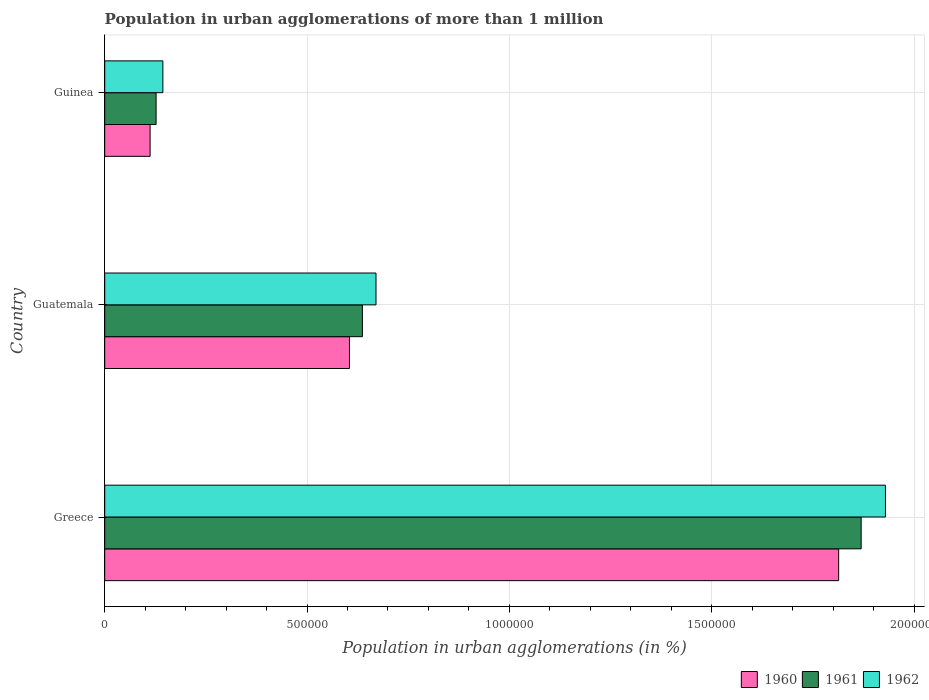How many different coloured bars are there?
Provide a succinct answer. 3. Are the number of bars on each tick of the Y-axis equal?
Your answer should be compact. Yes. How many bars are there on the 1st tick from the top?
Your response must be concise. 3. How many bars are there on the 2nd tick from the bottom?
Provide a short and direct response. 3. What is the label of the 1st group of bars from the top?
Your answer should be very brief. Guinea. In how many cases, is the number of bars for a given country not equal to the number of legend labels?
Your answer should be very brief. 0. What is the population in urban agglomerations in 1962 in Greece?
Your answer should be very brief. 1.93e+06. Across all countries, what is the maximum population in urban agglomerations in 1961?
Offer a terse response. 1.87e+06. Across all countries, what is the minimum population in urban agglomerations in 1962?
Ensure brevity in your answer.  1.44e+05. In which country was the population in urban agglomerations in 1960 minimum?
Give a very brief answer. Guinea. What is the total population in urban agglomerations in 1962 in the graph?
Offer a very short reply. 2.74e+06. What is the difference between the population in urban agglomerations in 1962 in Greece and that in Guatemala?
Make the answer very short. 1.26e+06. What is the difference between the population in urban agglomerations in 1961 in Guatemala and the population in urban agglomerations in 1960 in Guinea?
Your response must be concise. 5.25e+05. What is the average population in urban agglomerations in 1961 per country?
Your answer should be compact. 8.78e+05. What is the difference between the population in urban agglomerations in 1961 and population in urban agglomerations in 1960 in Guatemala?
Offer a terse response. 3.19e+04. What is the ratio of the population in urban agglomerations in 1961 in Greece to that in Guatemala?
Offer a very short reply. 2.94. Is the population in urban agglomerations in 1960 in Greece less than that in Guinea?
Provide a short and direct response. No. Is the difference between the population in urban agglomerations in 1961 in Greece and Guinea greater than the difference between the population in urban agglomerations in 1960 in Greece and Guinea?
Make the answer very short. Yes. What is the difference between the highest and the second highest population in urban agglomerations in 1961?
Your answer should be very brief. 1.23e+06. What is the difference between the highest and the lowest population in urban agglomerations in 1960?
Give a very brief answer. 1.70e+06. Is the sum of the population in urban agglomerations in 1960 in Greece and Guatemala greater than the maximum population in urban agglomerations in 1962 across all countries?
Your response must be concise. Yes. What does the 3rd bar from the top in Guatemala represents?
Your answer should be compact. 1960. What does the 1st bar from the bottom in Guinea represents?
Your answer should be very brief. 1960. Is it the case that in every country, the sum of the population in urban agglomerations in 1960 and population in urban agglomerations in 1961 is greater than the population in urban agglomerations in 1962?
Make the answer very short. Yes. How many bars are there?
Your response must be concise. 9. What is the difference between two consecutive major ticks on the X-axis?
Your answer should be very brief. 5.00e+05. Are the values on the major ticks of X-axis written in scientific E-notation?
Make the answer very short. No. Does the graph contain any zero values?
Make the answer very short. No. Does the graph contain grids?
Keep it short and to the point. Yes. Where does the legend appear in the graph?
Provide a short and direct response. Bottom right. How many legend labels are there?
Give a very brief answer. 3. What is the title of the graph?
Provide a succinct answer. Population in urban agglomerations of more than 1 million. What is the label or title of the X-axis?
Ensure brevity in your answer.  Population in urban agglomerations (in %). What is the Population in urban agglomerations (in %) of 1960 in Greece?
Ensure brevity in your answer.  1.81e+06. What is the Population in urban agglomerations (in %) of 1961 in Greece?
Make the answer very short. 1.87e+06. What is the Population in urban agglomerations (in %) of 1962 in Greece?
Ensure brevity in your answer.  1.93e+06. What is the Population in urban agglomerations (in %) in 1960 in Guatemala?
Your answer should be very brief. 6.05e+05. What is the Population in urban agglomerations (in %) of 1961 in Guatemala?
Your answer should be compact. 6.37e+05. What is the Population in urban agglomerations (in %) in 1962 in Guatemala?
Offer a very short reply. 6.70e+05. What is the Population in urban agglomerations (in %) in 1960 in Guinea?
Your answer should be very brief. 1.12e+05. What is the Population in urban agglomerations (in %) in 1961 in Guinea?
Provide a short and direct response. 1.27e+05. What is the Population in urban agglomerations (in %) of 1962 in Guinea?
Provide a short and direct response. 1.44e+05. Across all countries, what is the maximum Population in urban agglomerations (in %) in 1960?
Give a very brief answer. 1.81e+06. Across all countries, what is the maximum Population in urban agglomerations (in %) in 1961?
Provide a short and direct response. 1.87e+06. Across all countries, what is the maximum Population in urban agglomerations (in %) in 1962?
Your response must be concise. 1.93e+06. Across all countries, what is the minimum Population in urban agglomerations (in %) in 1960?
Ensure brevity in your answer.  1.12e+05. Across all countries, what is the minimum Population in urban agglomerations (in %) of 1961?
Your answer should be very brief. 1.27e+05. Across all countries, what is the minimum Population in urban agglomerations (in %) of 1962?
Provide a succinct answer. 1.44e+05. What is the total Population in urban agglomerations (in %) in 1960 in the graph?
Ensure brevity in your answer.  2.53e+06. What is the total Population in urban agglomerations (in %) of 1961 in the graph?
Your answer should be very brief. 2.63e+06. What is the total Population in urban agglomerations (in %) of 1962 in the graph?
Your answer should be very brief. 2.74e+06. What is the difference between the Population in urban agglomerations (in %) in 1960 in Greece and that in Guatemala?
Provide a succinct answer. 1.21e+06. What is the difference between the Population in urban agglomerations (in %) of 1961 in Greece and that in Guatemala?
Ensure brevity in your answer.  1.23e+06. What is the difference between the Population in urban agglomerations (in %) in 1962 in Greece and that in Guatemala?
Provide a short and direct response. 1.26e+06. What is the difference between the Population in urban agglomerations (in %) in 1960 in Greece and that in Guinea?
Provide a short and direct response. 1.70e+06. What is the difference between the Population in urban agglomerations (in %) in 1961 in Greece and that in Guinea?
Your answer should be very brief. 1.74e+06. What is the difference between the Population in urban agglomerations (in %) of 1962 in Greece and that in Guinea?
Ensure brevity in your answer.  1.79e+06. What is the difference between the Population in urban agglomerations (in %) in 1960 in Guatemala and that in Guinea?
Offer a very short reply. 4.93e+05. What is the difference between the Population in urban agglomerations (in %) of 1961 in Guatemala and that in Guinea?
Offer a very short reply. 5.10e+05. What is the difference between the Population in urban agglomerations (in %) in 1962 in Guatemala and that in Guinea?
Offer a very short reply. 5.27e+05. What is the difference between the Population in urban agglomerations (in %) of 1960 in Greece and the Population in urban agglomerations (in %) of 1961 in Guatemala?
Offer a very short reply. 1.18e+06. What is the difference between the Population in urban agglomerations (in %) of 1960 in Greece and the Population in urban agglomerations (in %) of 1962 in Guatemala?
Keep it short and to the point. 1.14e+06. What is the difference between the Population in urban agglomerations (in %) in 1961 in Greece and the Population in urban agglomerations (in %) in 1962 in Guatemala?
Provide a short and direct response. 1.20e+06. What is the difference between the Population in urban agglomerations (in %) of 1960 in Greece and the Population in urban agglomerations (in %) of 1961 in Guinea?
Offer a very short reply. 1.69e+06. What is the difference between the Population in urban agglomerations (in %) in 1960 in Greece and the Population in urban agglomerations (in %) in 1962 in Guinea?
Make the answer very short. 1.67e+06. What is the difference between the Population in urban agglomerations (in %) in 1961 in Greece and the Population in urban agglomerations (in %) in 1962 in Guinea?
Give a very brief answer. 1.73e+06. What is the difference between the Population in urban agglomerations (in %) in 1960 in Guatemala and the Population in urban agglomerations (in %) in 1961 in Guinea?
Make the answer very short. 4.78e+05. What is the difference between the Population in urban agglomerations (in %) of 1960 in Guatemala and the Population in urban agglomerations (in %) of 1962 in Guinea?
Provide a short and direct response. 4.61e+05. What is the difference between the Population in urban agglomerations (in %) of 1961 in Guatemala and the Population in urban agglomerations (in %) of 1962 in Guinea?
Give a very brief answer. 4.93e+05. What is the average Population in urban agglomerations (in %) in 1960 per country?
Offer a terse response. 8.44e+05. What is the average Population in urban agglomerations (in %) of 1961 per country?
Offer a terse response. 8.78e+05. What is the average Population in urban agglomerations (in %) of 1962 per country?
Make the answer very short. 9.14e+05. What is the difference between the Population in urban agglomerations (in %) of 1960 and Population in urban agglomerations (in %) of 1961 in Greece?
Your answer should be very brief. -5.56e+04. What is the difference between the Population in urban agglomerations (in %) of 1960 and Population in urban agglomerations (in %) of 1962 in Greece?
Offer a terse response. -1.16e+05. What is the difference between the Population in urban agglomerations (in %) of 1961 and Population in urban agglomerations (in %) of 1962 in Greece?
Your answer should be compact. -6.00e+04. What is the difference between the Population in urban agglomerations (in %) of 1960 and Population in urban agglomerations (in %) of 1961 in Guatemala?
Provide a succinct answer. -3.19e+04. What is the difference between the Population in urban agglomerations (in %) of 1960 and Population in urban agglomerations (in %) of 1962 in Guatemala?
Your answer should be very brief. -6.56e+04. What is the difference between the Population in urban agglomerations (in %) in 1961 and Population in urban agglomerations (in %) in 1962 in Guatemala?
Provide a succinct answer. -3.37e+04. What is the difference between the Population in urban agglomerations (in %) in 1960 and Population in urban agglomerations (in %) in 1961 in Guinea?
Your answer should be compact. -1.48e+04. What is the difference between the Population in urban agglomerations (in %) of 1960 and Population in urban agglomerations (in %) of 1962 in Guinea?
Provide a short and direct response. -3.15e+04. What is the difference between the Population in urban agglomerations (in %) in 1961 and Population in urban agglomerations (in %) in 1962 in Guinea?
Your answer should be compact. -1.68e+04. What is the ratio of the Population in urban agglomerations (in %) in 1960 in Greece to that in Guatemala?
Give a very brief answer. 3. What is the ratio of the Population in urban agglomerations (in %) in 1961 in Greece to that in Guatemala?
Give a very brief answer. 2.94. What is the ratio of the Population in urban agglomerations (in %) in 1962 in Greece to that in Guatemala?
Provide a short and direct response. 2.88. What is the ratio of the Population in urban agglomerations (in %) of 1960 in Greece to that in Guinea?
Provide a succinct answer. 16.17. What is the ratio of the Population in urban agglomerations (in %) in 1961 in Greece to that in Guinea?
Your answer should be very brief. 14.73. What is the ratio of the Population in urban agglomerations (in %) of 1962 in Greece to that in Guinea?
Your response must be concise. 13.43. What is the ratio of the Population in urban agglomerations (in %) of 1960 in Guatemala to that in Guinea?
Offer a very short reply. 5.39. What is the ratio of the Population in urban agglomerations (in %) of 1961 in Guatemala to that in Guinea?
Your answer should be compact. 5.02. What is the ratio of the Population in urban agglomerations (in %) in 1962 in Guatemala to that in Guinea?
Keep it short and to the point. 4.67. What is the difference between the highest and the second highest Population in urban agglomerations (in %) of 1960?
Provide a short and direct response. 1.21e+06. What is the difference between the highest and the second highest Population in urban agglomerations (in %) of 1961?
Your answer should be compact. 1.23e+06. What is the difference between the highest and the second highest Population in urban agglomerations (in %) of 1962?
Provide a short and direct response. 1.26e+06. What is the difference between the highest and the lowest Population in urban agglomerations (in %) of 1960?
Provide a succinct answer. 1.70e+06. What is the difference between the highest and the lowest Population in urban agglomerations (in %) in 1961?
Your response must be concise. 1.74e+06. What is the difference between the highest and the lowest Population in urban agglomerations (in %) of 1962?
Ensure brevity in your answer.  1.79e+06. 